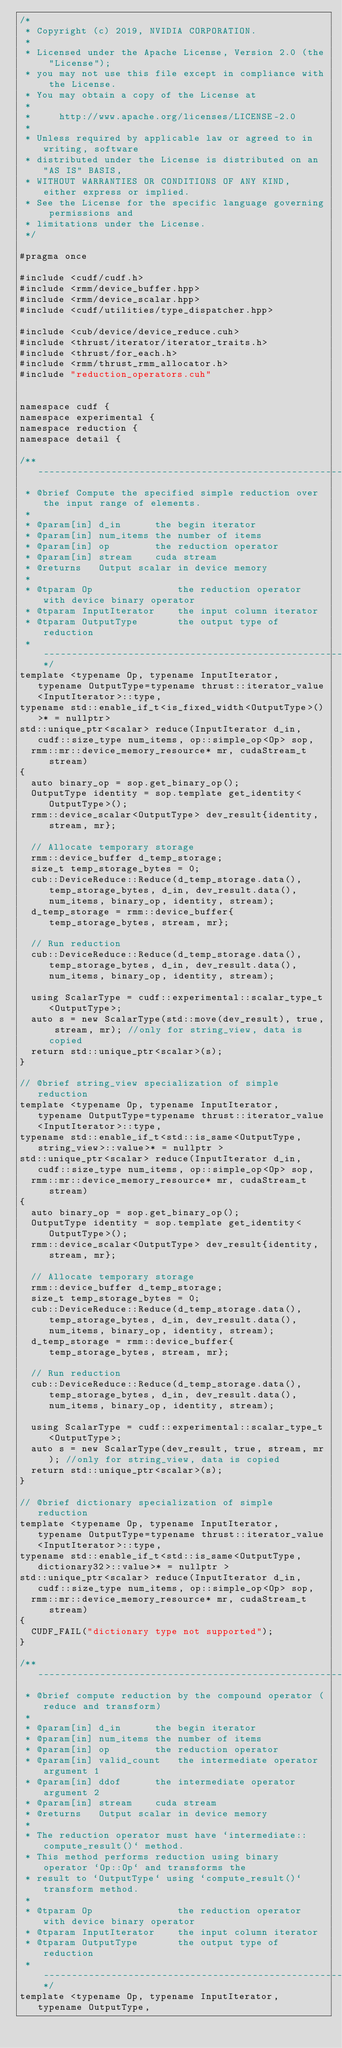Convert code to text. <code><loc_0><loc_0><loc_500><loc_500><_Cuda_>/*
 * Copyright (c) 2019, NVIDIA CORPORATION.
 *
 * Licensed under the Apache License, Version 2.0 (the "License");
 * you may not use this file except in compliance with the License.
 * You may obtain a copy of the License at
 *
 *     http://www.apache.org/licenses/LICENSE-2.0
 *
 * Unless required by applicable law or agreed to in writing, software
 * distributed under the License is distributed on an "AS IS" BASIS,
 * WITHOUT WARRANTIES OR CONDITIONS OF ANY KIND, either express or implied.
 * See the License for the specific language governing permissions and
 * limitations under the License.
 */

#pragma once

#include <cudf/cudf.h>
#include <rmm/device_buffer.hpp>
#include <rmm/device_scalar.hpp>
#include <cudf/utilities/type_dispatcher.hpp>

#include <cub/device/device_reduce.cuh>
#include <thrust/iterator/iterator_traits.h>
#include <thrust/for_each.h>
#include <rmm/thrust_rmm_allocator.h>
#include "reduction_operators.cuh"


namespace cudf {
namespace experimental {
namespace reduction {
namespace detail {

/** --------------------------------------------------------------------------*
 * @brief Compute the specified simple reduction over the input range of elements.
 *
 * @param[in] d_in      the begin iterator
 * @param[in] num_items the number of items
 * @param[in] op        the reduction operator
 * @param[in] stream    cuda stream
 * @returns   Output scalar in device memory
 *
 * @tparam Op               the reduction operator with device binary operator
 * @tparam InputIterator    the input column iterator
 * @tparam OutputType       the output type of reduction
 * ----------------------------------------------------------------------------**/
template <typename Op, typename InputIterator, typename OutputType=typename thrust::iterator_value<InputIterator>::type,
typename std::enable_if_t<is_fixed_width<OutputType>()>* = nullptr>
std::unique_ptr<scalar> reduce(InputIterator d_in, cudf::size_type num_items, op::simple_op<Op> sop,
  rmm::mr::device_memory_resource* mr, cudaStream_t stream)
{
  auto binary_op = sop.get_binary_op();
  OutputType identity = sop.template get_identity<OutputType>();
  rmm::device_scalar<OutputType> dev_result{identity, stream, mr};

  // Allocate temporary storage
  rmm::device_buffer d_temp_storage;
  size_t temp_storage_bytes = 0;
  cub::DeviceReduce::Reduce(d_temp_storage.data(), temp_storage_bytes, d_in, dev_result.data(), num_items, binary_op, identity, stream);
  d_temp_storage = rmm::device_buffer{temp_storage_bytes, stream, mr};

  // Run reduction
  cub::DeviceReduce::Reduce(d_temp_storage.data(), temp_storage_bytes, d_in, dev_result.data(), num_items, binary_op, identity, stream);

  using ScalarType = cudf::experimental::scalar_type_t<OutputType>;
  auto s = new ScalarType(std::move(dev_result), true, stream, mr); //only for string_view, data is copied
  return std::unique_ptr<scalar>(s);
}

// @brief string_view specialization of simple reduction
template <typename Op, typename InputIterator, typename OutputType=typename thrust::iterator_value<InputIterator>::type,
typename std::enable_if_t<std::is_same<OutputType, string_view>::value>* = nullptr >
std::unique_ptr<scalar> reduce(InputIterator d_in, cudf::size_type num_items, op::simple_op<Op> sop,
  rmm::mr::device_memory_resource* mr, cudaStream_t stream)
{
  auto binary_op = sop.get_binary_op();
  OutputType identity = sop.template get_identity<OutputType>();
  rmm::device_scalar<OutputType> dev_result{identity, stream, mr};

  // Allocate temporary storage
  rmm::device_buffer d_temp_storage;
  size_t temp_storage_bytes = 0;
  cub::DeviceReduce::Reduce(d_temp_storage.data(), temp_storage_bytes, d_in, dev_result.data(), num_items, binary_op, identity, stream);
  d_temp_storage = rmm::device_buffer{temp_storage_bytes, stream, mr};

  // Run reduction
  cub::DeviceReduce::Reduce(d_temp_storage.data(), temp_storage_bytes, d_in, dev_result.data(), num_items, binary_op, identity, stream);

  using ScalarType = cudf::experimental::scalar_type_t<OutputType>;
  auto s = new ScalarType(dev_result, true, stream, mr); //only for string_view, data is copied
  return std::unique_ptr<scalar>(s);
}

// @brief dictionary specialization of simple reduction
template <typename Op, typename InputIterator, typename OutputType=typename thrust::iterator_value<InputIterator>::type,
typename std::enable_if_t<std::is_same<OutputType, dictionary32>::value>* = nullptr >
std::unique_ptr<scalar> reduce(InputIterator d_in, cudf::size_type num_items, op::simple_op<Op> sop,
  rmm::mr::device_memory_resource* mr, cudaStream_t stream)
{
  CUDF_FAIL("dictionary type not supported");
}

/** --------------------------------------------------------------------------*
 * @brief compute reduction by the compound operator (reduce and transform)
 *
 * @param[in] d_in      the begin iterator
 * @param[in] num_items the number of items
 * @param[in] op        the reduction operator 
 * @param[in] valid_count   the intermediate operator argument 1
 * @param[in] ddof      the intermediate operator argument 2
 * @param[in] stream    cuda stream
 * @returns   Output scalar in device memory
 *
 * The reduction operator must have `intermediate::compute_result()` method.
 * This method performs reduction using binary operator `Op::Op` and transforms the
 * result to `OutputType` using `compute_result()` transform method.
 *
 * @tparam Op               the reduction operator with device binary operator
 * @tparam InputIterator    the input column iterator
 * @tparam OutputType       the output type of reduction
 * ----------------------------------------------------------------------------**/
template <typename Op, typename InputIterator, typename OutputType, </code> 